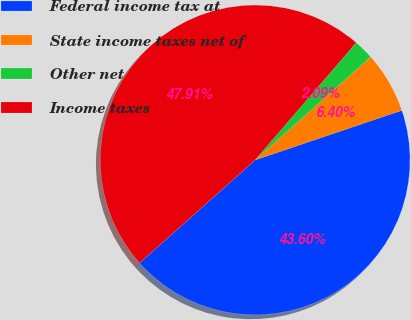Convert chart to OTSL. <chart><loc_0><loc_0><loc_500><loc_500><pie_chart><fcel>Federal income tax at<fcel>State income taxes net of<fcel>Other net<fcel>Income taxes<nl><fcel>43.6%<fcel>6.4%<fcel>2.09%<fcel>47.91%<nl></chart> 